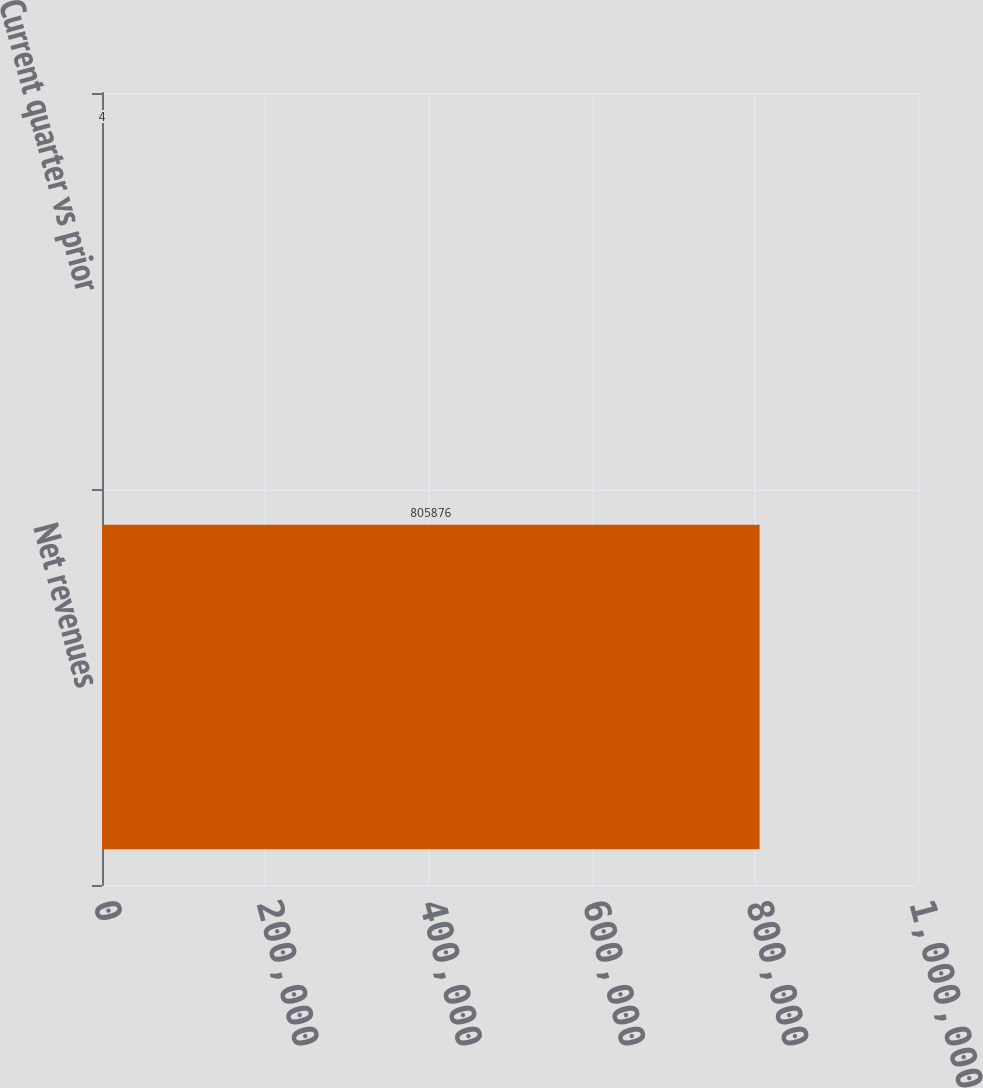<chart> <loc_0><loc_0><loc_500><loc_500><bar_chart><fcel>Net revenues<fcel>Current quarter vs prior<nl><fcel>805876<fcel>4<nl></chart> 